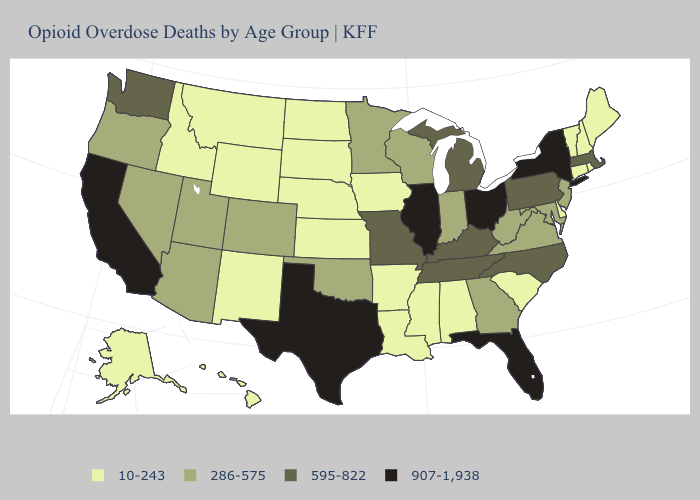Among the states that border Utah , does Nevada have the lowest value?
Give a very brief answer. No. Does Ohio have the lowest value in the MidWest?
Quick response, please. No. Does Florida have the highest value in the USA?
Short answer required. Yes. What is the highest value in states that border Wyoming?
Write a very short answer. 286-575. Is the legend a continuous bar?
Keep it brief. No. What is the highest value in states that border California?
Short answer required. 286-575. Does Texas have the highest value in the South?
Quick response, please. Yes. Which states hav the highest value in the MidWest?
Write a very short answer. Illinois, Ohio. Does Utah have a higher value than North Carolina?
Quick response, please. No. How many symbols are there in the legend?
Answer briefly. 4. Does South Dakota have the lowest value in the MidWest?
Quick response, please. Yes. Is the legend a continuous bar?
Answer briefly. No. Does Washington have a higher value than Ohio?
Give a very brief answer. No. What is the value of Delaware?
Be succinct. 10-243. 